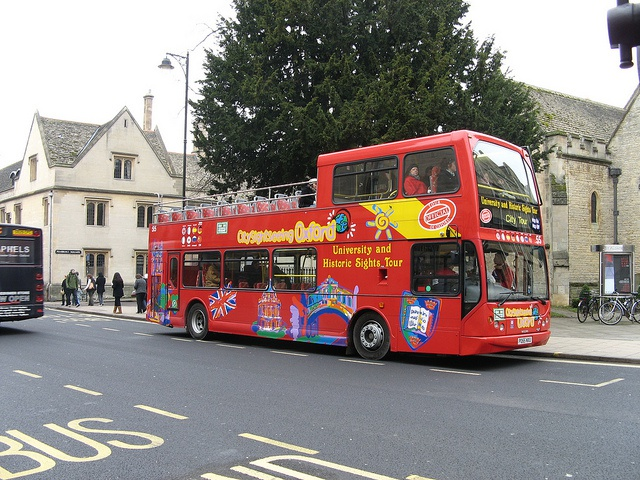Describe the objects in this image and their specific colors. I can see bus in white, black, brown, and gray tones, bus in white, black, gray, and darkgray tones, bicycle in white, gray, darkgray, black, and lightgray tones, people in white, black, and gray tones, and people in white, brown, maroon, and gray tones in this image. 